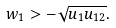Convert formula to latex. <formula><loc_0><loc_0><loc_500><loc_500>w _ { 1 } > - \sqrt { u _ { 1 } u _ { 1 2 } } .</formula> 